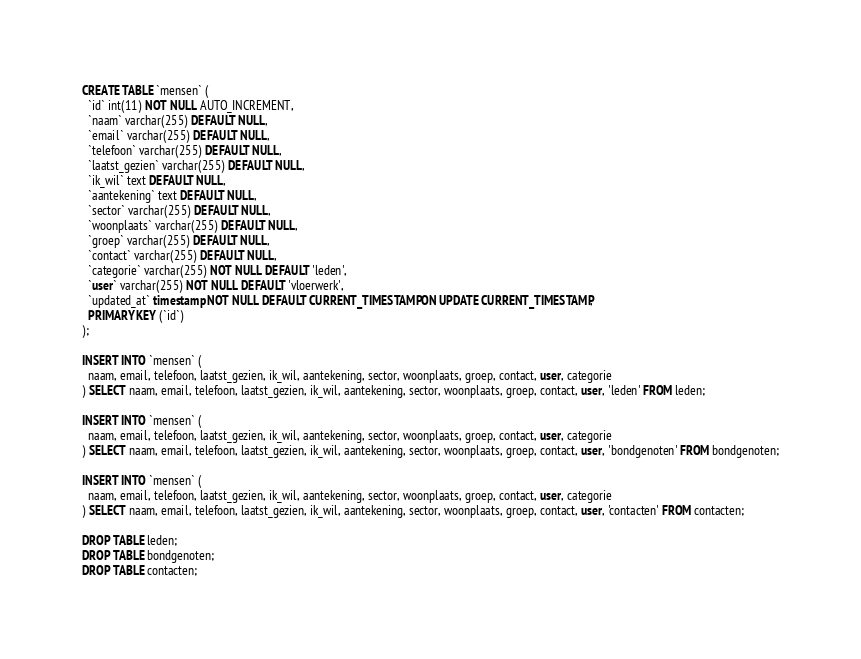Convert code to text. <code><loc_0><loc_0><loc_500><loc_500><_SQL_>CREATE TABLE `mensen` (
  `id` int(11) NOT NULL AUTO_INCREMENT,
  `naam` varchar(255) DEFAULT NULL,
  `email` varchar(255) DEFAULT NULL,
  `telefoon` varchar(255) DEFAULT NULL,
  `laatst_gezien` varchar(255) DEFAULT NULL,
  `ik_wil` text DEFAULT NULL,
  `aantekening` text DEFAULT NULL,
  `sector` varchar(255) DEFAULT NULL,
  `woonplaats` varchar(255) DEFAULT NULL,
  `groep` varchar(255) DEFAULT NULL,
  `contact` varchar(255) DEFAULT NULL,
  `categorie` varchar(255) NOT NULL DEFAULT 'leden',
  `user` varchar(255) NOT NULL DEFAULT 'vloerwerk',
  `updated_at` timestamp NOT NULL DEFAULT CURRENT_TIMESTAMP ON UPDATE CURRENT_TIMESTAMP,
  PRIMARY KEY (`id`)
);

INSERT INTO `mensen` (
  naam, email, telefoon, laatst_gezien, ik_wil, aantekening, sector, woonplaats, groep, contact, user, categorie
) SELECT naam, email, telefoon, laatst_gezien, ik_wil, aantekening, sector, woonplaats, groep, contact, user, 'leden' FROM leden;

INSERT INTO `mensen` (
  naam, email, telefoon, laatst_gezien, ik_wil, aantekening, sector, woonplaats, groep, contact, user, categorie
) SELECT naam, email, telefoon, laatst_gezien, ik_wil, aantekening, sector, woonplaats, groep, contact, user, 'bondgenoten' FROM bondgenoten;

INSERT INTO `mensen` (
  naam, email, telefoon, laatst_gezien, ik_wil, aantekening, sector, woonplaats, groep, contact, user, categorie
) SELECT naam, email, telefoon, laatst_gezien, ik_wil, aantekening, sector, woonplaats, groep, contact, user, 'contacten' FROM contacten;

DROP TABLE leden;
DROP TABLE bondgenoten;
DROP TABLE contacten;</code> 